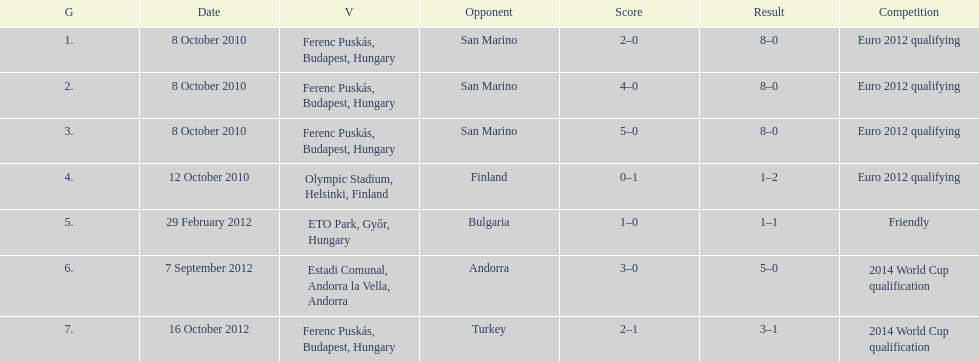Szalai scored all but one of his international goals in either euro 2012 qualifying or what other level of play? 2014 World Cup qualification. 